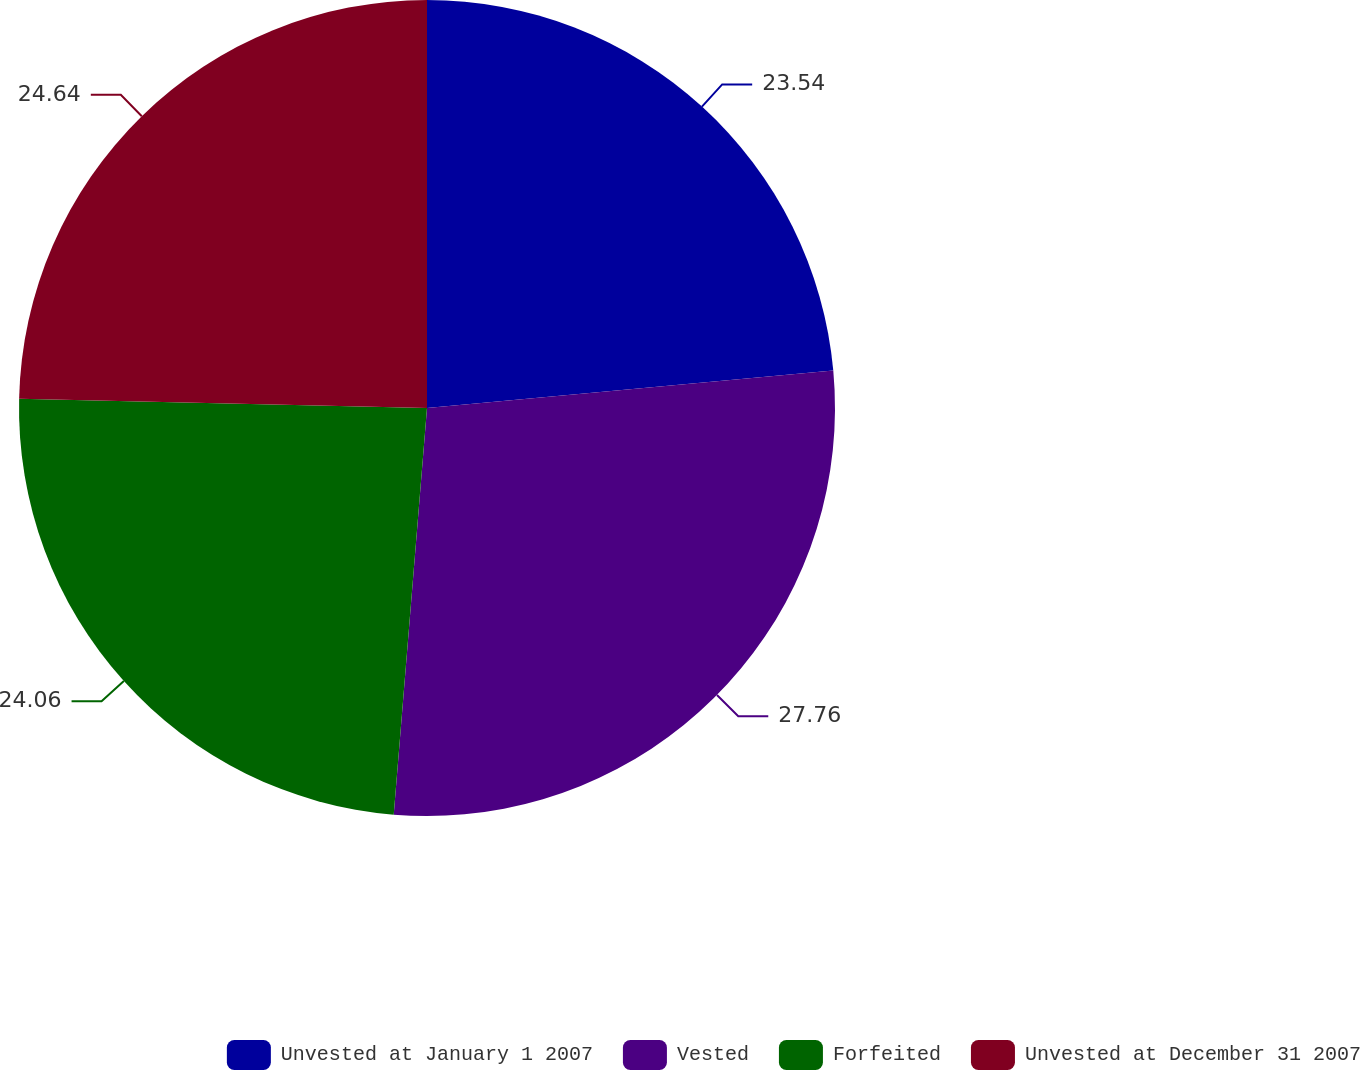Convert chart. <chart><loc_0><loc_0><loc_500><loc_500><pie_chart><fcel>Unvested at January 1 2007<fcel>Vested<fcel>Forfeited<fcel>Unvested at December 31 2007<nl><fcel>23.54%<fcel>27.76%<fcel>24.06%<fcel>24.64%<nl></chart> 